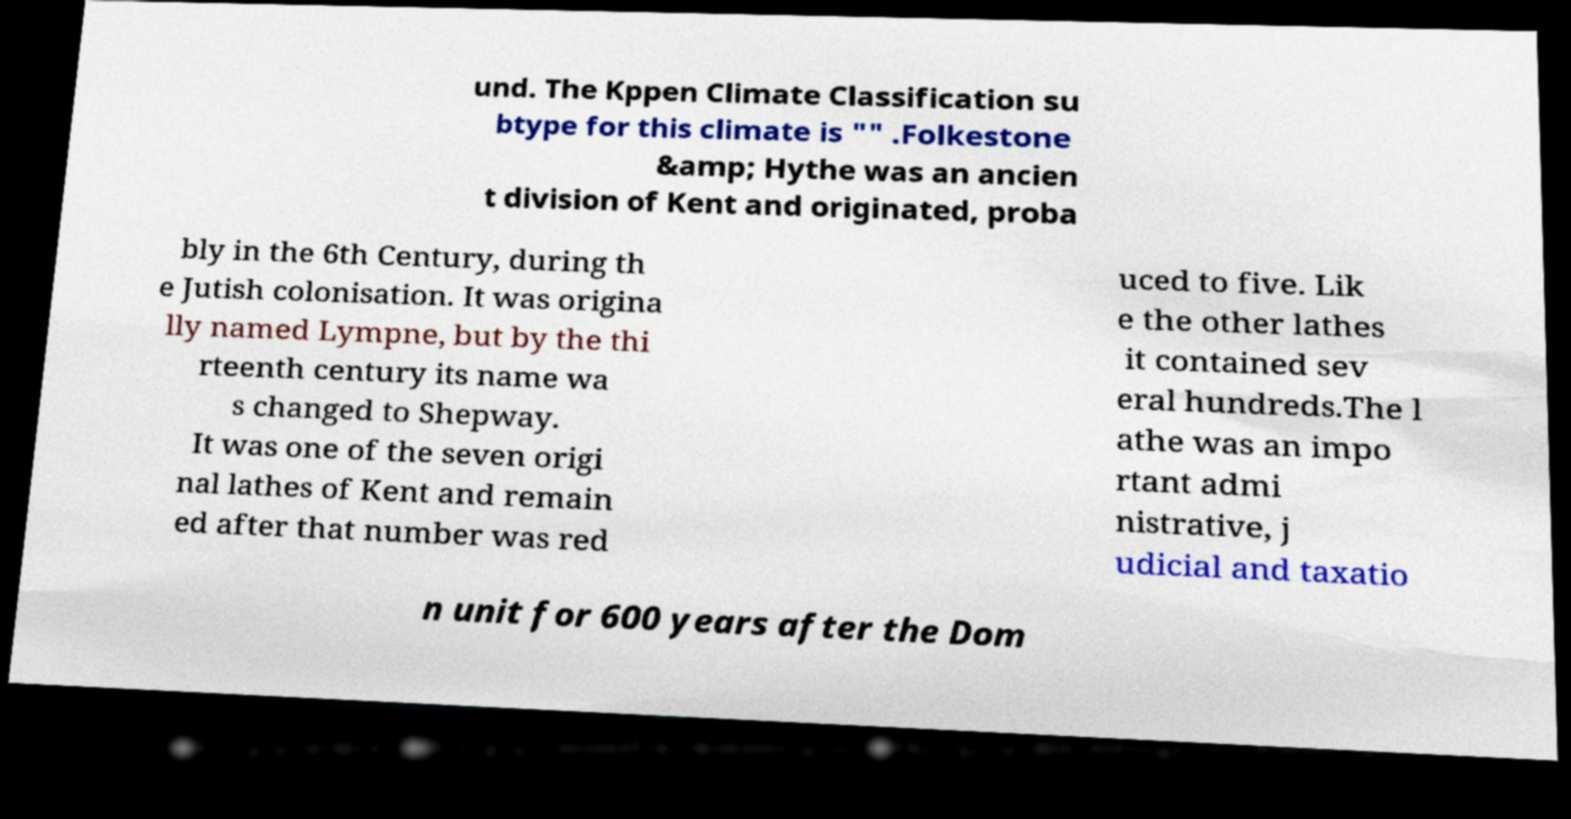Can you accurately transcribe the text from the provided image for me? und. The Kppen Climate Classification su btype for this climate is "" .Folkestone &amp; Hythe was an ancien t division of Kent and originated, proba bly in the 6th Century, during th e Jutish colonisation. It was origina lly named Lympne, but by the thi rteenth century its name wa s changed to Shepway. It was one of the seven origi nal lathes of Kent and remain ed after that number was red uced to five. Lik e the other lathes it contained sev eral hundreds.The l athe was an impo rtant admi nistrative, j udicial and taxatio n unit for 600 years after the Dom 